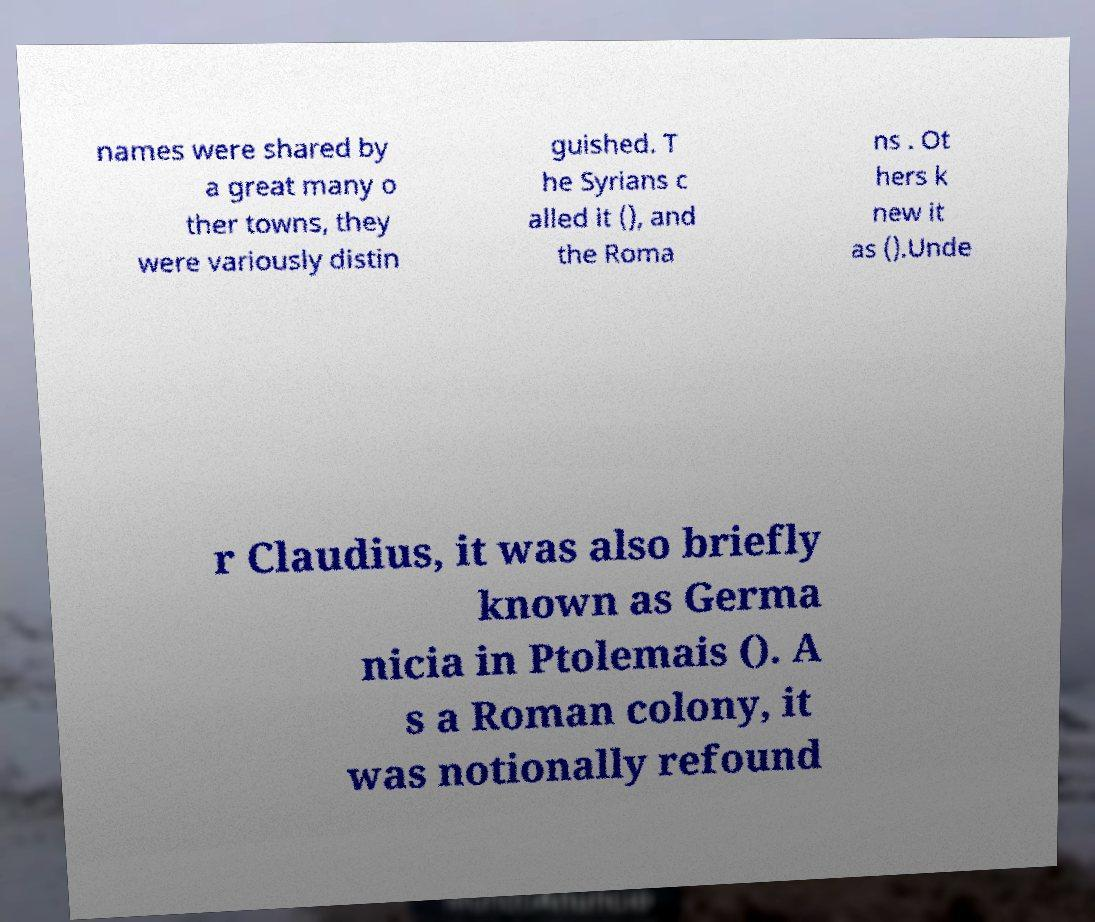Could you extract and type out the text from this image? names were shared by a great many o ther towns, they were variously distin guished. T he Syrians c alled it (), and the Roma ns . Ot hers k new it as ().Unde r Claudius, it was also briefly known as Germa nicia in Ptolemais (). A s a Roman colony, it was notionally refound 